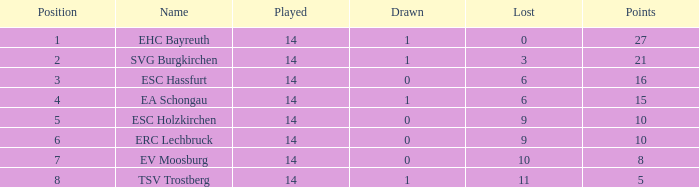What's the most points for Ea Schongau with more than 1 drawn? None. 